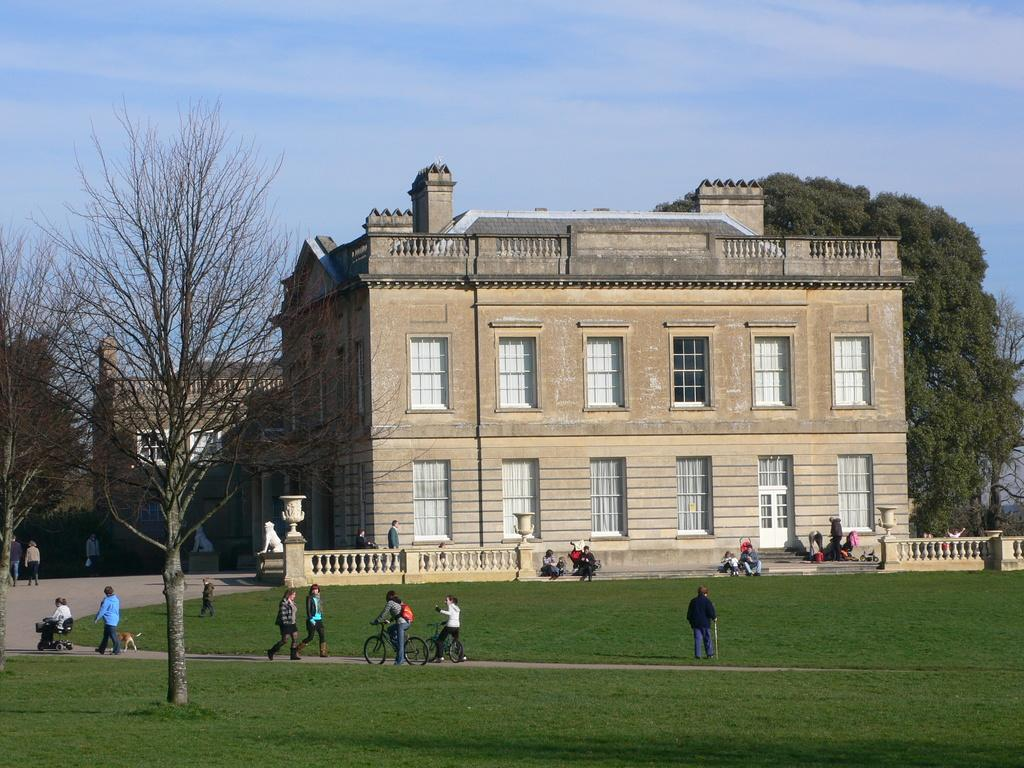What type of vegetation is present in the image? There is grass in the image. What are the two persons doing in the image? They are riding bicycles. What other natural elements can be seen in the image? There are trees in the image. What type of structures are visible in the image? There are buildings in the image. What architectural feature can be seen on the buildings? There are windows in the image. What is visible in the background of the image? The sky is visible in the background of the image. How much salt is being used by the person riding the bicycle in the image? There is no salt present in the image, and the person riding the bicycle is not using any salt. What type of yarn is being used by the trees in the image? There is no yarn present in the image, and the trees are not using any yarn. 